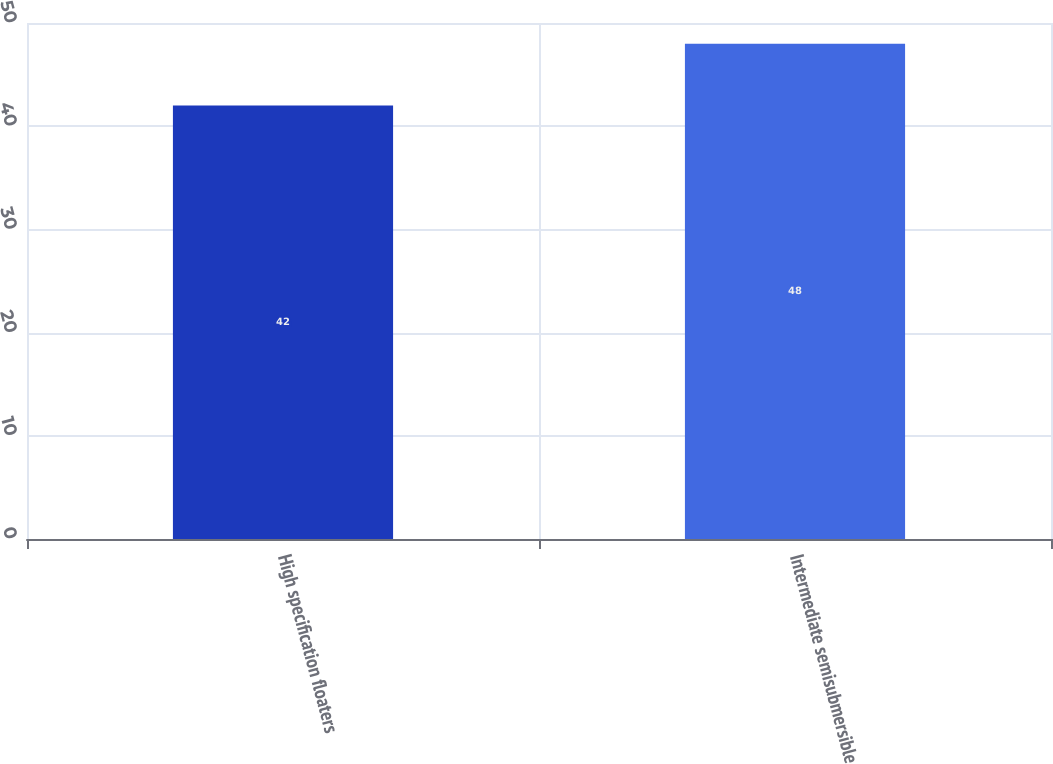<chart> <loc_0><loc_0><loc_500><loc_500><bar_chart><fcel>High specification floaters<fcel>Intermediate semisubmersible<nl><fcel>42<fcel>48<nl></chart> 